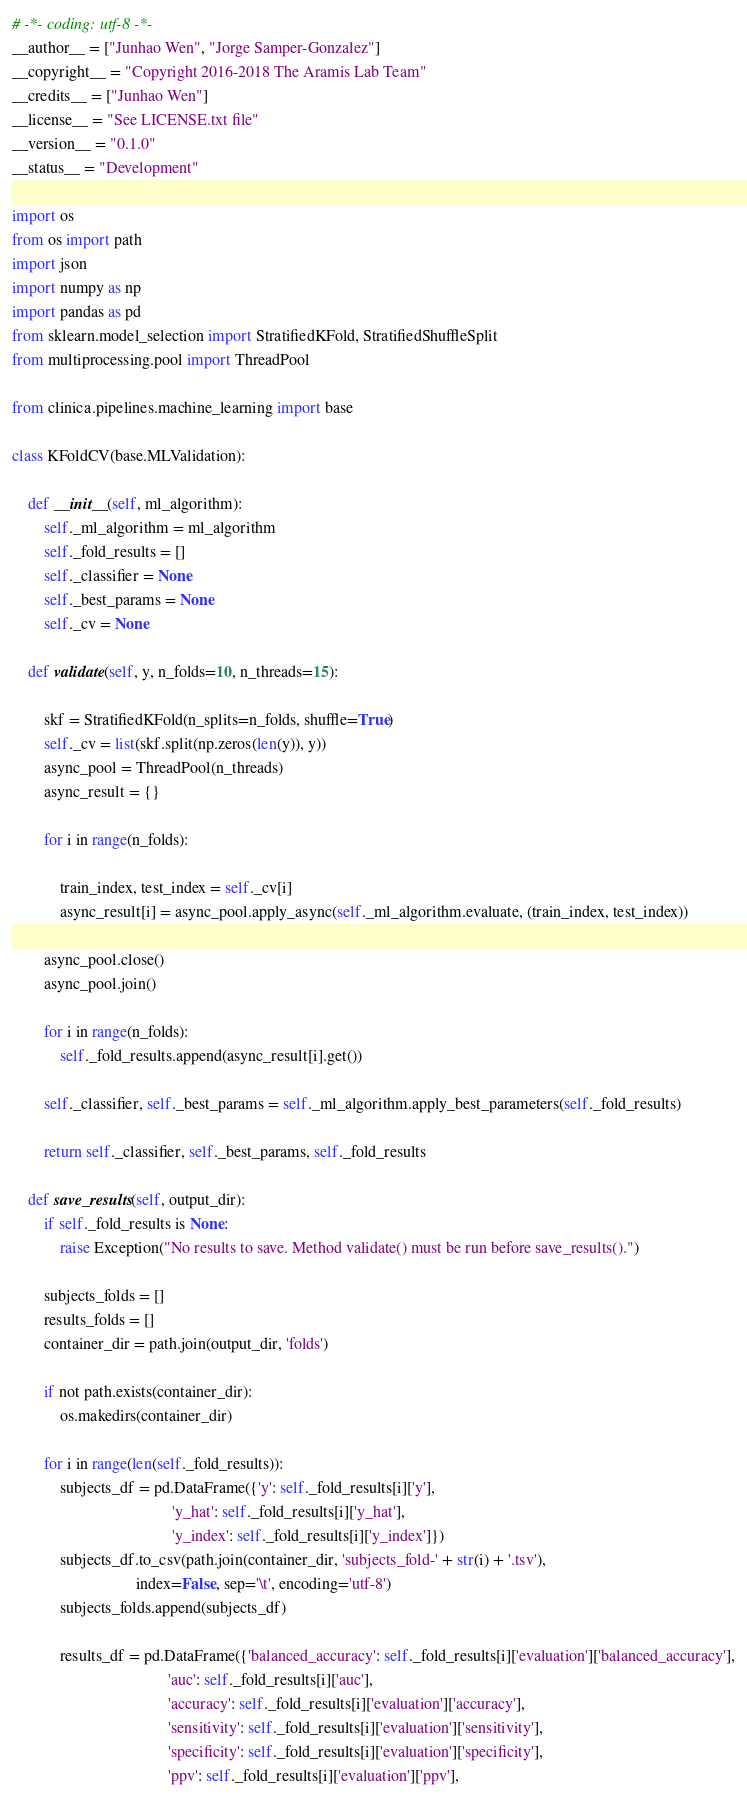Convert code to text. <code><loc_0><loc_0><loc_500><loc_500><_Python_># -*- coding: utf-8 -*-
__author__ = ["Junhao Wen", "Jorge Samper-Gonzalez"]
__copyright__ = "Copyright 2016-2018 The Aramis Lab Team"
__credits__ = ["Junhao Wen"]
__license__ = "See LICENSE.txt file"
__version__ = "0.1.0"
__status__ = "Development"

import os
from os import path
import json
import numpy as np
import pandas as pd
from sklearn.model_selection import StratifiedKFold, StratifiedShuffleSplit
from multiprocessing.pool import ThreadPool

from clinica.pipelines.machine_learning import base

class KFoldCV(base.MLValidation):

    def __init__(self, ml_algorithm):
        self._ml_algorithm = ml_algorithm
        self._fold_results = []
        self._classifier = None
        self._best_params = None
        self._cv = None

    def validate(self, y, n_folds=10, n_threads=15):

        skf = StratifiedKFold(n_splits=n_folds, shuffle=True)
        self._cv = list(skf.split(np.zeros(len(y)), y))
        async_pool = ThreadPool(n_threads)
        async_result = {}

        for i in range(n_folds):

            train_index, test_index = self._cv[i]
            async_result[i] = async_pool.apply_async(self._ml_algorithm.evaluate, (train_index, test_index))

        async_pool.close()
        async_pool.join()

        for i in range(n_folds):
            self._fold_results.append(async_result[i].get())

        self._classifier, self._best_params = self._ml_algorithm.apply_best_parameters(self._fold_results)

        return self._classifier, self._best_params, self._fold_results

    def save_results(self, output_dir):
        if self._fold_results is None:
            raise Exception("No results to save. Method validate() must be run before save_results().")

        subjects_folds = []
        results_folds = []
        container_dir = path.join(output_dir, 'folds')

        if not path.exists(container_dir):
            os.makedirs(container_dir)

        for i in range(len(self._fold_results)):
            subjects_df = pd.DataFrame({'y': self._fold_results[i]['y'],
                                        'y_hat': self._fold_results[i]['y_hat'],
                                        'y_index': self._fold_results[i]['y_index']})
            subjects_df.to_csv(path.join(container_dir, 'subjects_fold-' + str(i) + '.tsv'),
                               index=False, sep='\t', encoding='utf-8')
            subjects_folds.append(subjects_df)

            results_df = pd.DataFrame({'balanced_accuracy': self._fold_results[i]['evaluation']['balanced_accuracy'],
                                       'auc': self._fold_results[i]['auc'],
                                       'accuracy': self._fold_results[i]['evaluation']['accuracy'],
                                       'sensitivity': self._fold_results[i]['evaluation']['sensitivity'],
                                       'specificity': self._fold_results[i]['evaluation']['specificity'],
                                       'ppv': self._fold_results[i]['evaluation']['ppv'],</code> 